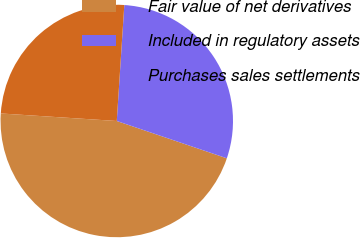<chart> <loc_0><loc_0><loc_500><loc_500><pie_chart><fcel>Fair value of net derivatives<fcel>Included in regulatory assets<fcel>Purchases sales settlements<nl><fcel>45.83%<fcel>29.17%<fcel>25.0%<nl></chart> 